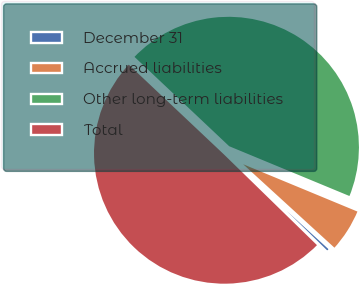Convert chart to OTSL. <chart><loc_0><loc_0><loc_500><loc_500><pie_chart><fcel>December 31<fcel>Accrued liabilities<fcel>Other long-term liabilities<fcel>Total<nl><fcel>0.51%<fcel>5.54%<fcel>44.21%<fcel>49.74%<nl></chart> 